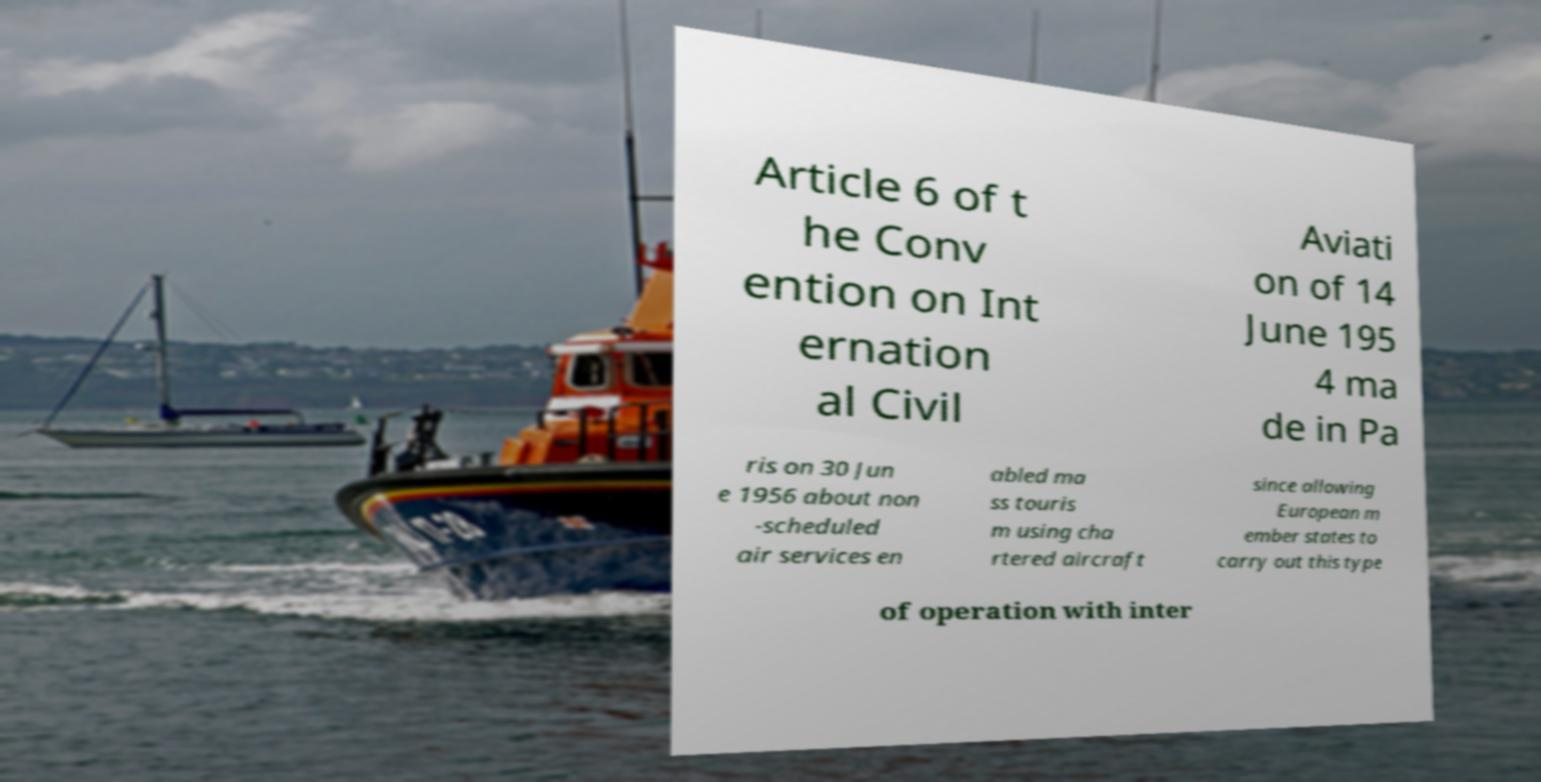I need the written content from this picture converted into text. Can you do that? Article 6 of t he Conv ention on Int ernation al Civil Aviati on of 14 June 195 4 ma de in Pa ris on 30 Jun e 1956 about non -scheduled air services en abled ma ss touris m using cha rtered aircraft since allowing European m ember states to carry out this type of operation with inter 